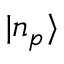<formula> <loc_0><loc_0><loc_500><loc_500>| n _ { p } \rangle</formula> 